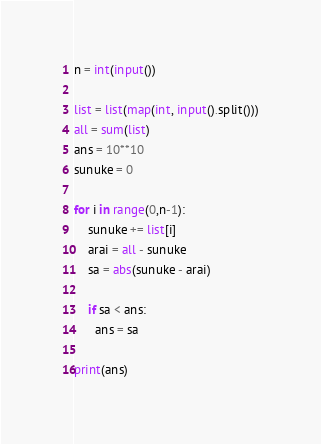Convert code to text. <code><loc_0><loc_0><loc_500><loc_500><_Python_>n = int(input())

list = list(map(int, input().split()))
all = sum(list)
ans = 10**10
sunuke = 0

for i in range(0,n-1):
    sunuke += list[i]
    arai = all - sunuke
    sa = abs(sunuke - arai)
   
    if sa < ans:
      ans = sa

print(ans)
</code> 